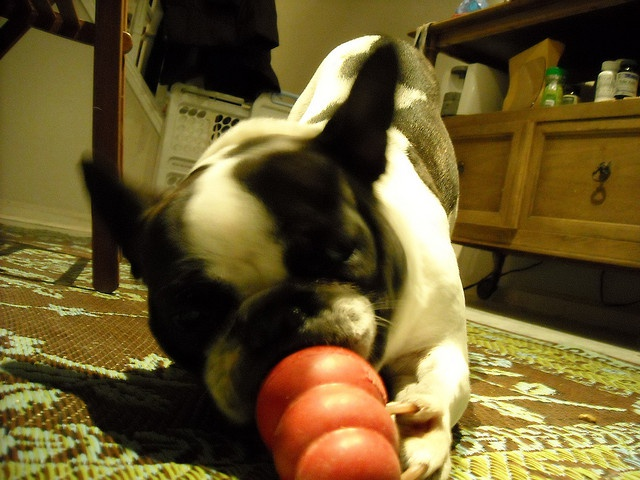Describe the objects in this image and their specific colors. I can see dog in black, khaki, olive, and beige tones, chair in black, olive, and maroon tones, sports ball in black, red, orange, maroon, and brown tones, sports ball in black, orange, maroon, red, and brown tones, and sports ball in black, red, orange, brown, and khaki tones in this image. 